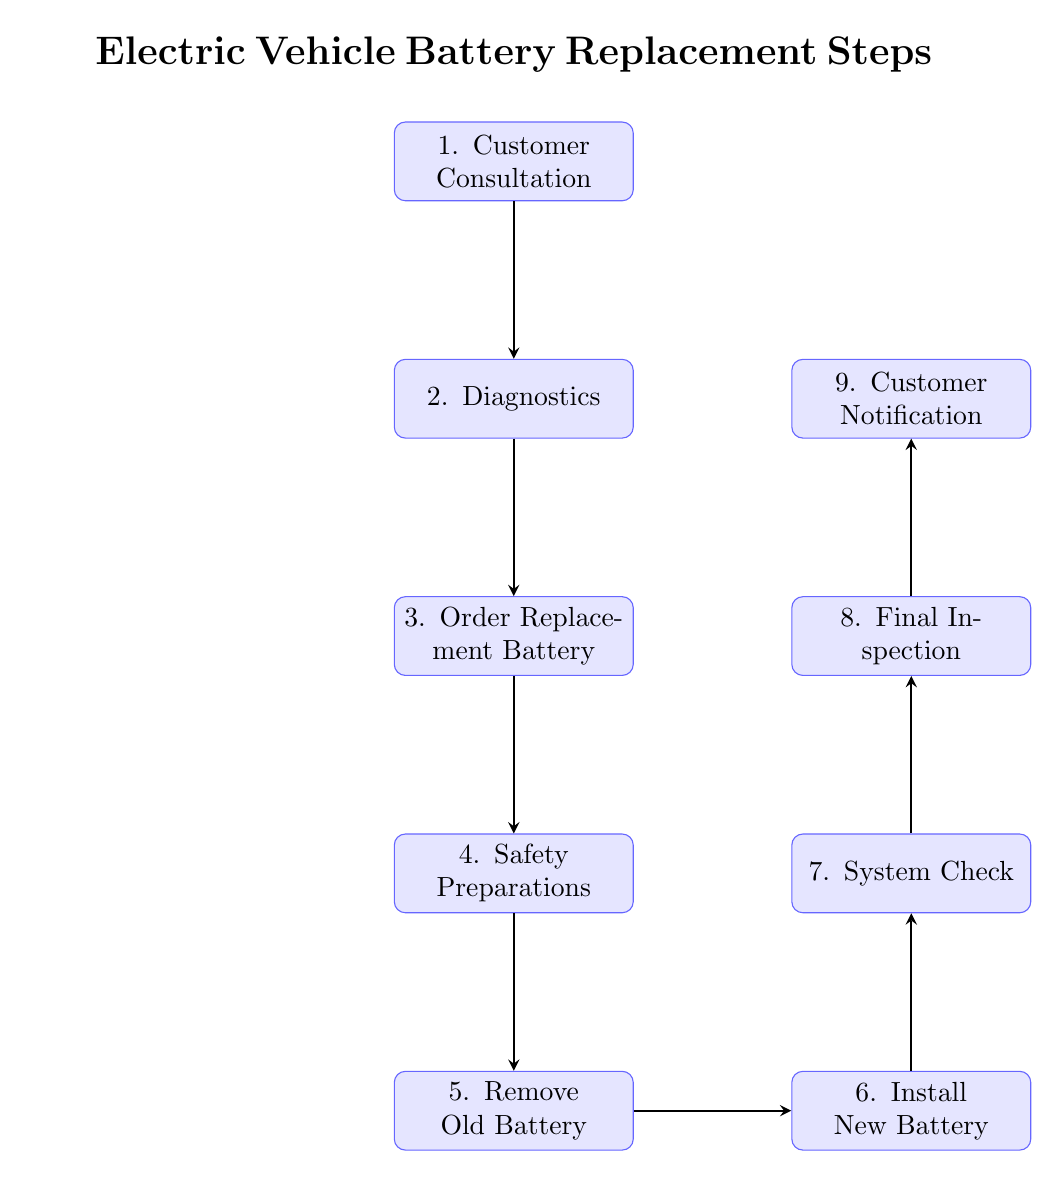What is the first step in the battery replacement process? The first step in the diagram is "Customer Consultation," which indicates that the process begins with a discussion with the customer to understand the issues with their vehicle.
Answer: Customer Consultation How many total steps are there in the battery replacement process? The diagram includes nine distinct steps in the battery replacement process, from customer consultation to customer notification.
Answer: Nine Which step comes immediately after the "Install New Battery"? The step that comes immediately after "Install New Battery" is "System Check," which indicates that a system check is performed following the battery installation.
Answer: System Check What safety measures need to be taken before removing the old battery? The "Safety Preparations" step indicates that safety protocols must be established, which includes disconnecting the battery and wearing protective gear.
Answer: Safety protocols Describe the relationship between the "Remove Old Battery" and "Customer Notification" steps. "Remove Old Battery" is a step that occurs earlier in the process and directly leads to the installation of the new battery, whereas "Customer Notification" is the final step which occurs after testing and inspecting the vehicle, indicating completion of the process.
Answer: Removes the old before notification In which step do you confirm the battery health? The step where battery health is confirmed is "Diagnostics," which involves performing diagnostics on the battery to check its condition and identify any issues.
Answer: Diagnostics What action is taken in the third step? In the third step, "Order Replacement Battery," the action taken is to order the correct replacement battery model based on the vehicle's make and model.
Answer: Order the correct battery model How is the final acknowledgment communicated to the customer? The final acknowledgment is communicated to the customer in the "Customer Notification" step, which involves notifying the customer that their vehicle is ready for pickup and providing necessary documentation.
Answer: Notify the customer Which step follows the "System Check"? The step that follows "System Check" is "Final Inspection," indicating that after checking the system, a final inspection is conducted before the vehicle is confirmed as ready.
Answer: Final Inspection 